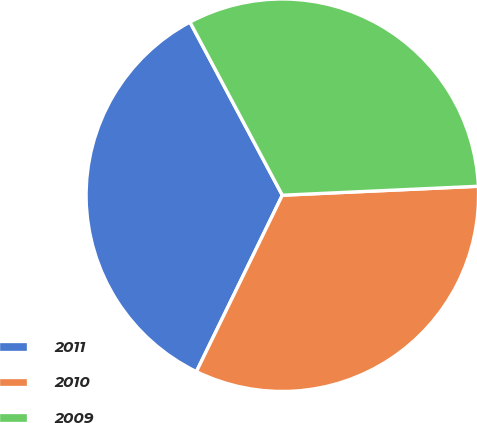<chart> <loc_0><loc_0><loc_500><loc_500><pie_chart><fcel>2011<fcel>2010<fcel>2009<nl><fcel>34.98%<fcel>32.94%<fcel>32.07%<nl></chart> 